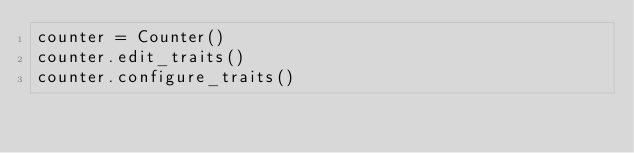Convert code to text. <code><loc_0><loc_0><loc_500><loc_500><_Python_>counter = Counter()
counter.edit_traits()
counter.configure_traits()
</code> 